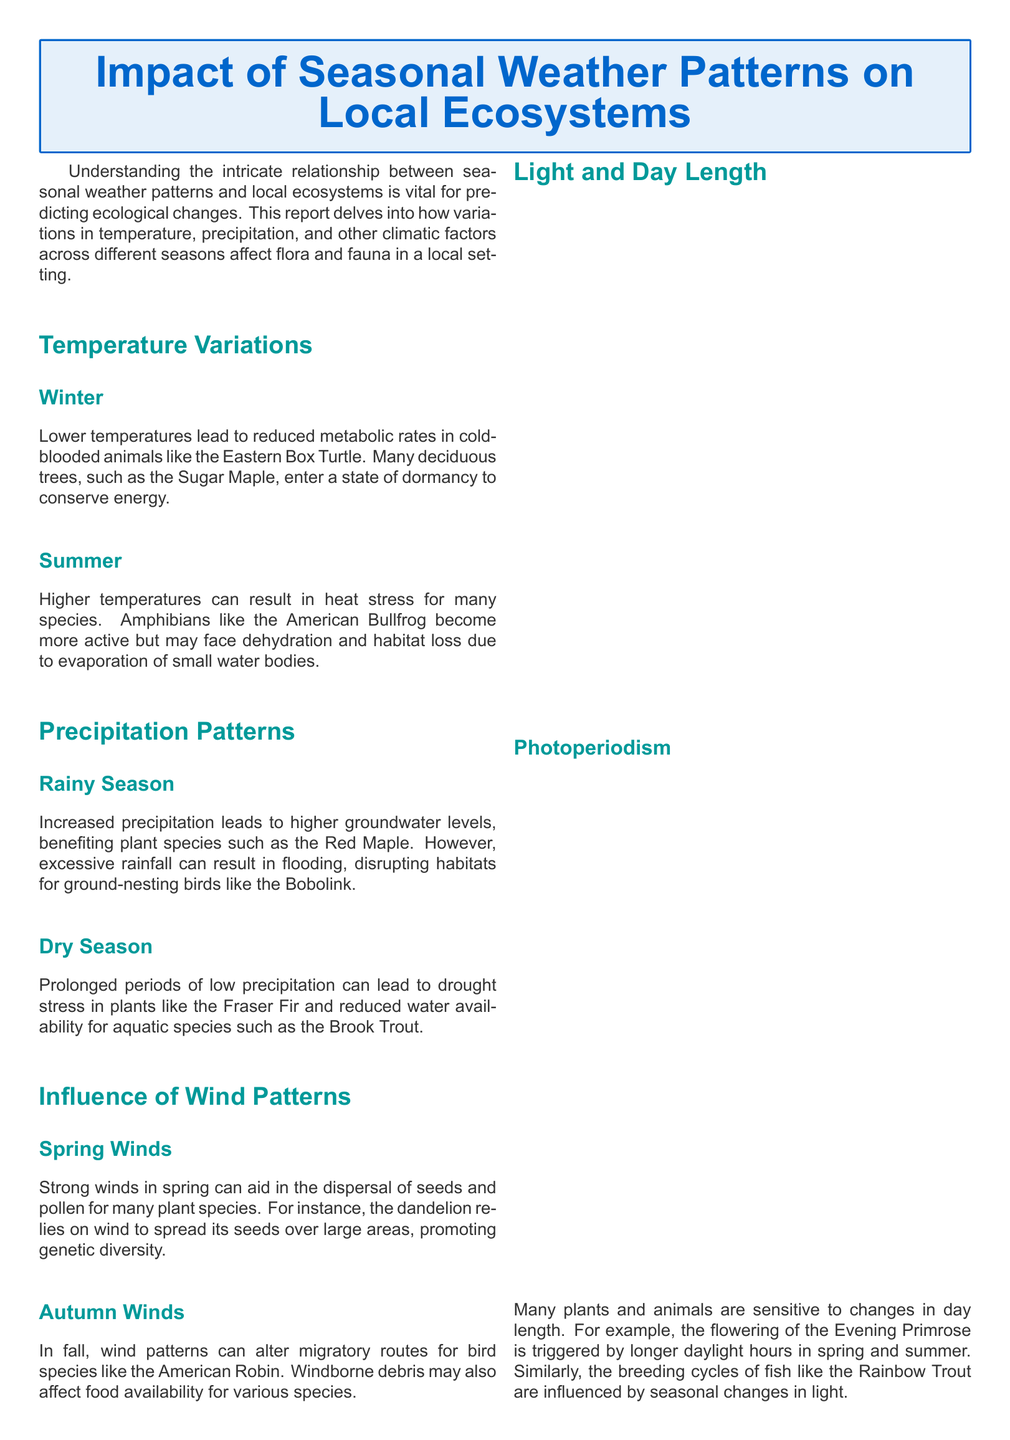what affects metabolic rates in winter? The document states that lower temperatures lead to reduced metabolic rates in cold-blooded animals.
Answer: lower temperatures which plant enters dormancy during winter? The report mentions that many deciduous trees, such as the Sugar Maple, enter a state of dormancy to conserve energy.
Answer: Sugar Maple how do higher temperatures impact amphibians in summer? The document explains that higher temperatures can result in heat stress for many species, affecting amphibians like the American Bullfrog.
Answer: heat stress what happens to groundwater levels during the rainy season? The report indicates that increased precipitation leads to higher groundwater levels.
Answer: higher groundwater levels which species benefits from wind in spring? The document states that strong winds in spring can aid in the dispersal of seeds and pollen for many plant species, such as the dandelion.
Answer: dandelion what can excessive rainfall cause for ground-nesting birds? The report highlights that excessive rainfall can result in flooding, disrupting habitats for ground-nesting birds.
Answer: flooding how does light influence the flowering of the Evening Primrose? The document mentions that the flowering of the Evening Primrose is triggered by longer daylight hours in spring and summer.
Answer: longer daylight hours what type of report is this? The document investigates the relationship between seasonal weather patterns and local ecosystems.
Answer: Weather report 